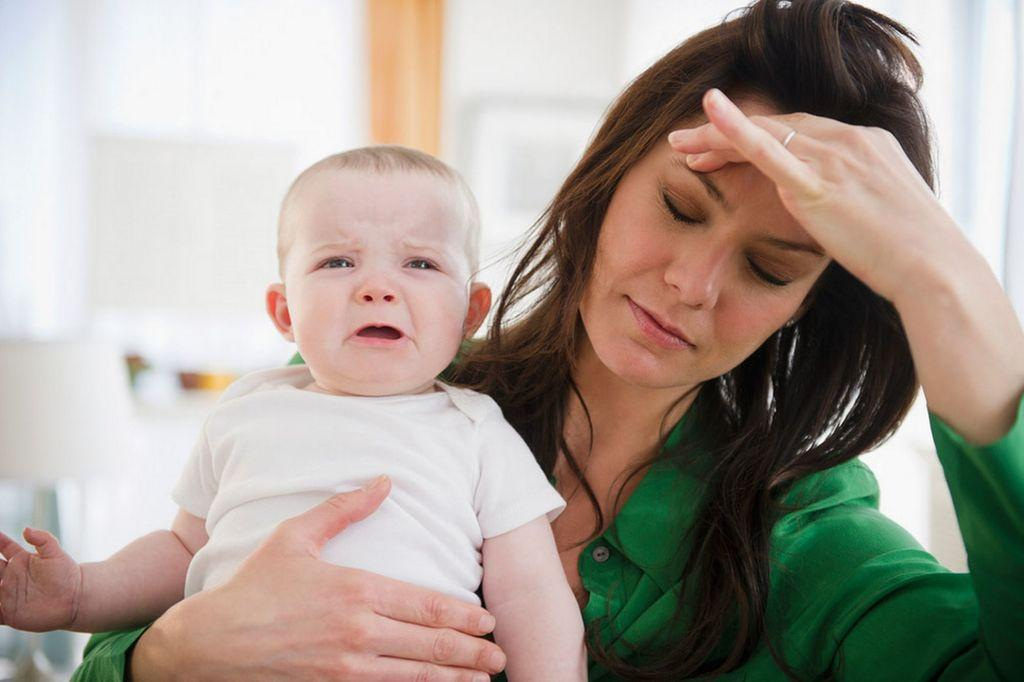Who is the main subject in the image? There is a woman in the image. What is the woman doing in the image? The woman is holding a baby. How is the baby behaving in the image? The baby is crying. Can you describe the background of the image? The background of the image is blurry. What type of country can be seen in the background of the image? There is no country visible in the background of the image; it is blurry. What kind of branch is supporting the woman and baby in the image? There is no branch present in the image; the woman and baby are not being supported by any visible object. 